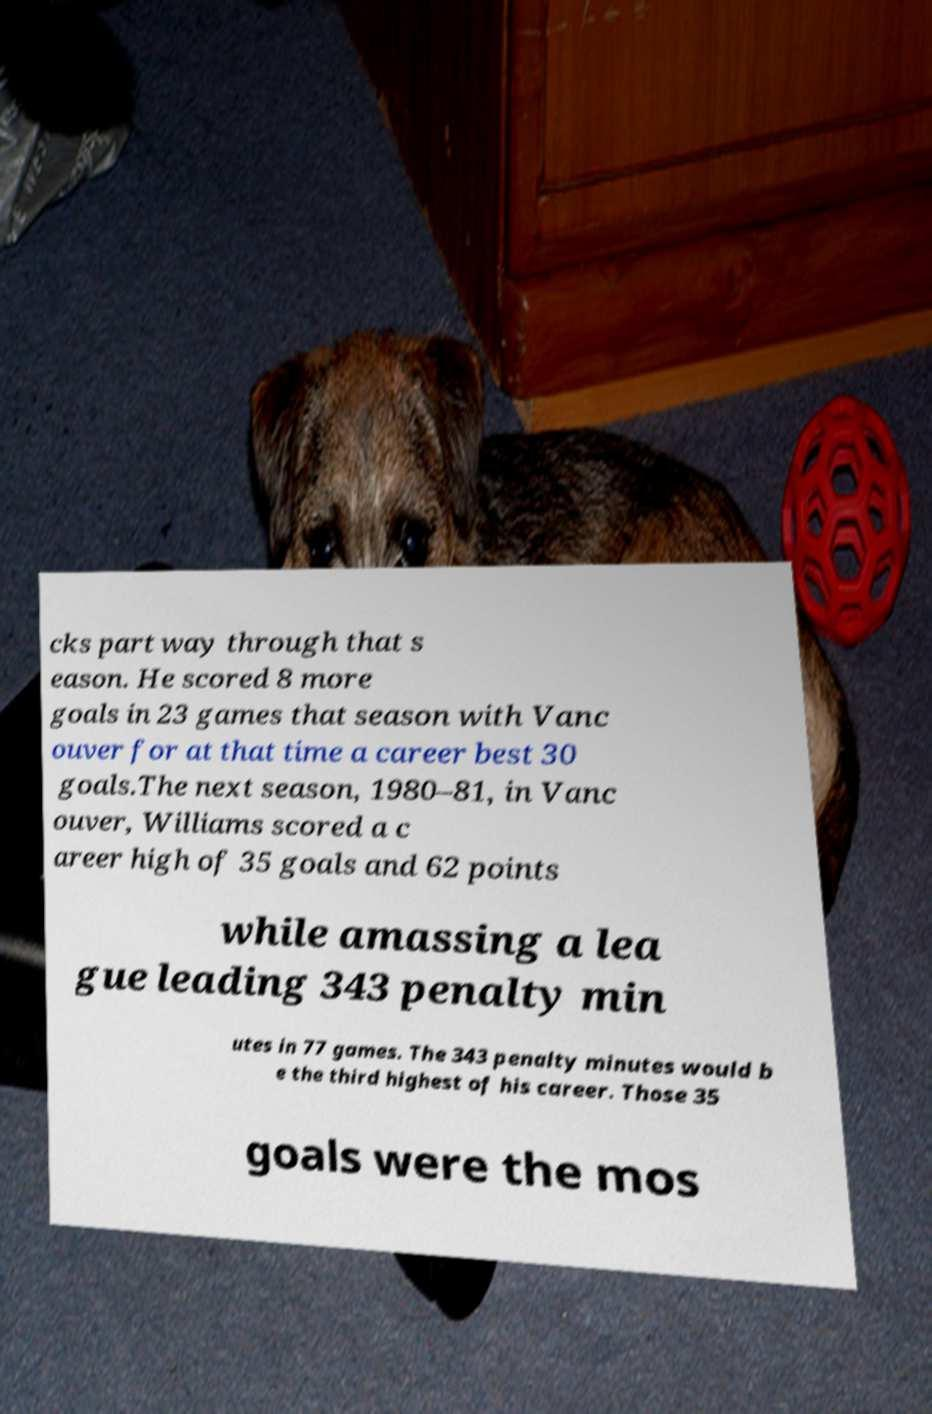I need the written content from this picture converted into text. Can you do that? cks part way through that s eason. He scored 8 more goals in 23 games that season with Vanc ouver for at that time a career best 30 goals.The next season, 1980–81, in Vanc ouver, Williams scored a c areer high of 35 goals and 62 points while amassing a lea gue leading 343 penalty min utes in 77 games. The 343 penalty minutes would b e the third highest of his career. Those 35 goals were the mos 